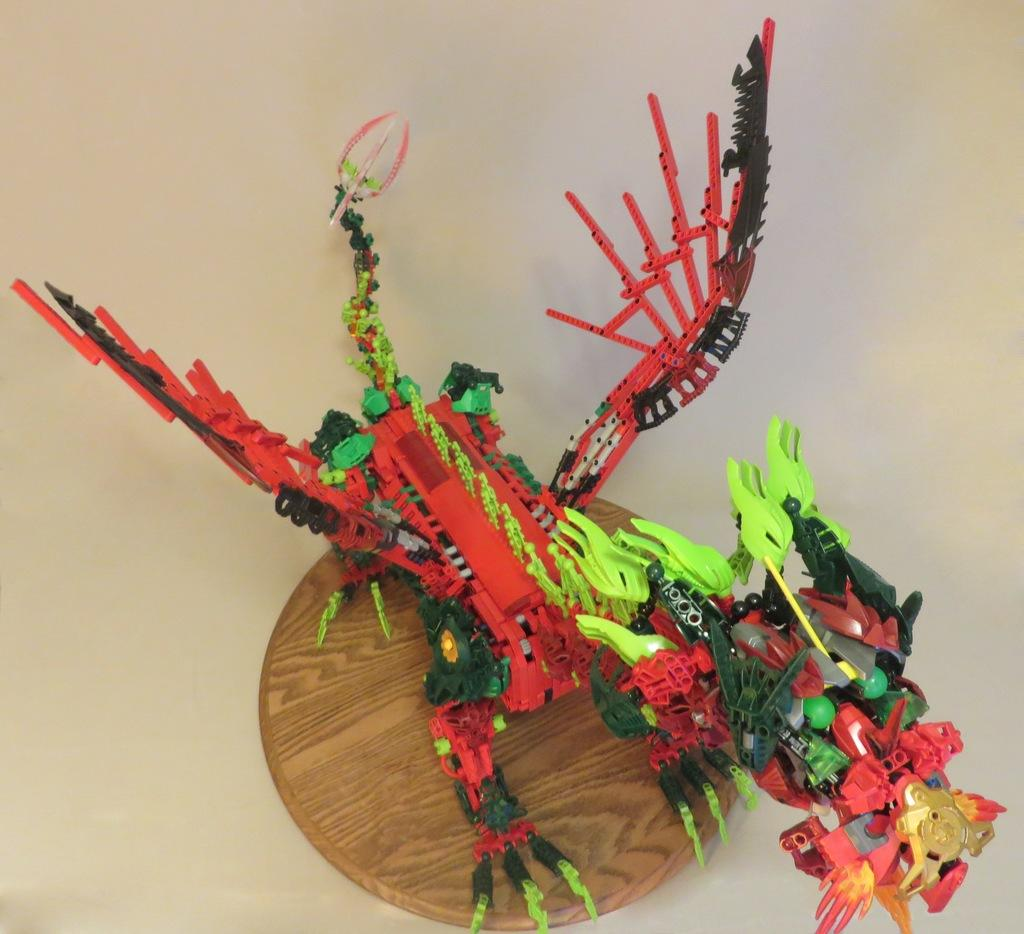What is the main object in the image? There is a wooden platter in the image. What is placed on the wooden platter? There is a toy on the wooden platter. On what surface is the wooden platter placed? The wooden platter is placed on a white surface. What type of coat is draped over the toy on the wooden platter? There is no coat present in the image; only a wooden platter with a toy on it is visible. 